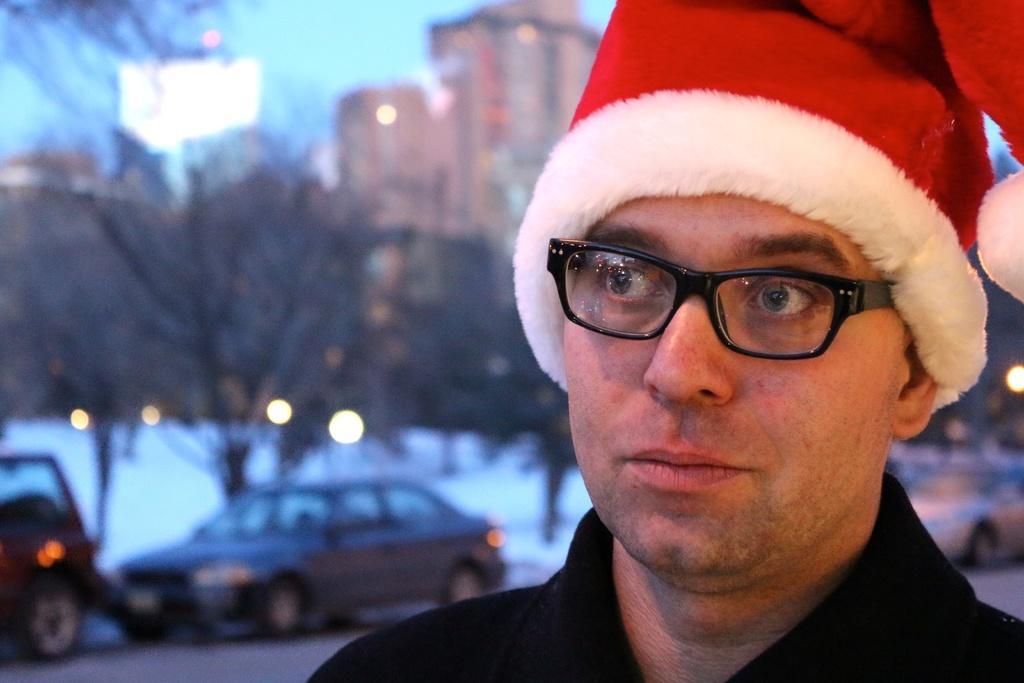Could you give a brief overview of what you see in this image? In this image I can see a person wearing a cap and a blurred background. I can see some cars, lights, trees and buildings in this background.  